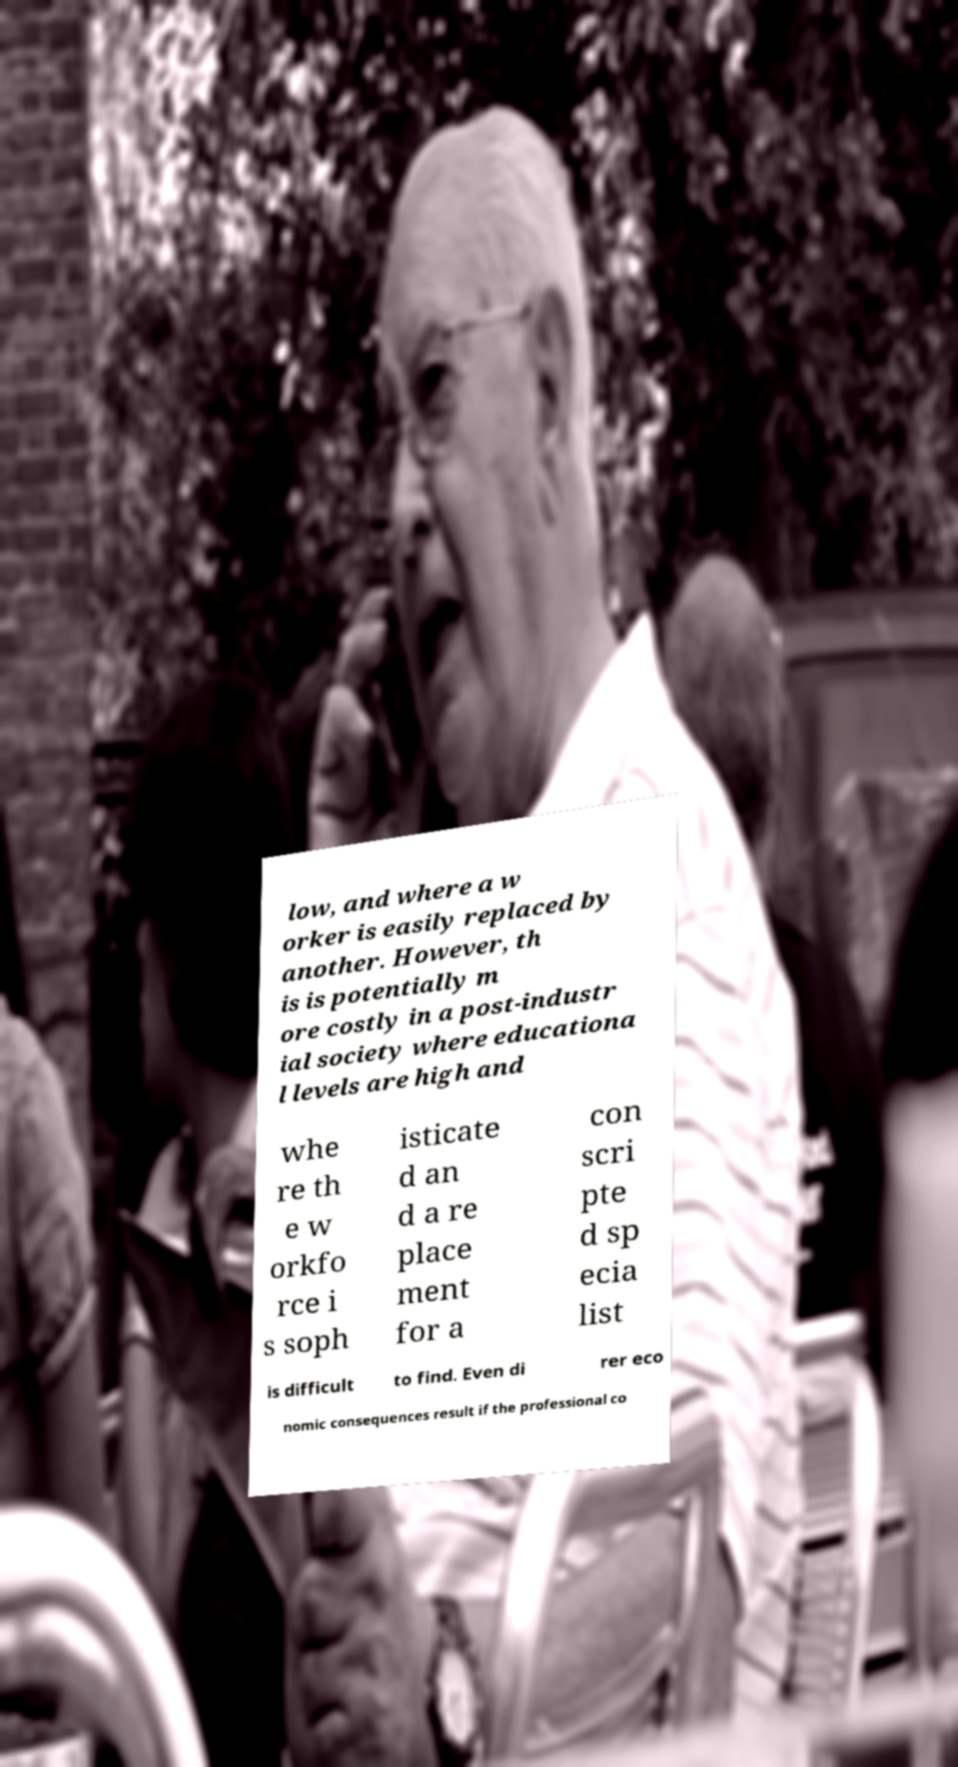Could you extract and type out the text from this image? low, and where a w orker is easily replaced by another. However, th is is potentially m ore costly in a post-industr ial society where educationa l levels are high and whe re th e w orkfo rce i s soph isticate d an d a re place ment for a con scri pte d sp ecia list is difficult to find. Even di rer eco nomic consequences result if the professional co 